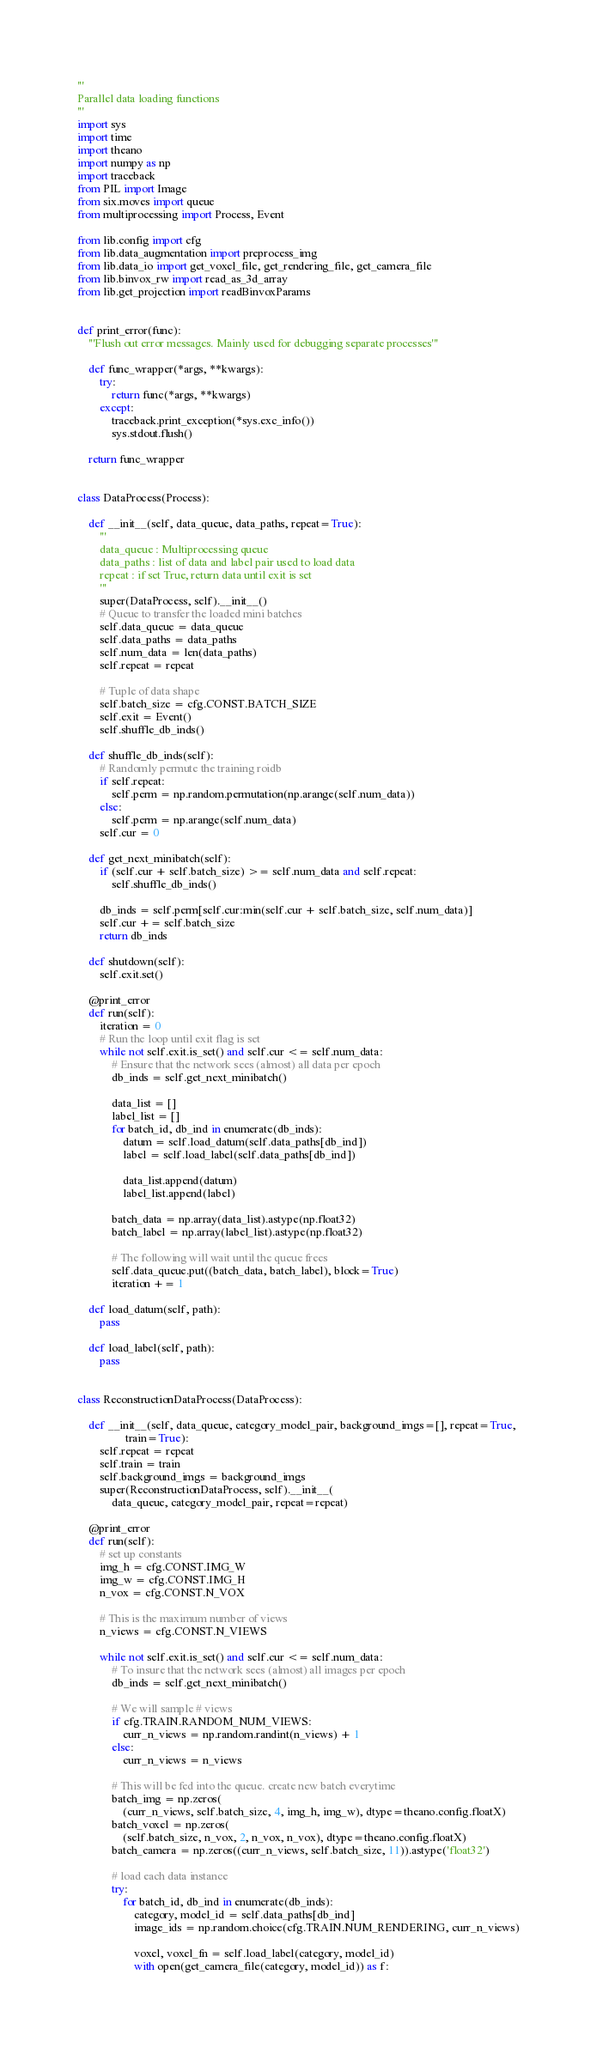Convert code to text. <code><loc_0><loc_0><loc_500><loc_500><_Python_>'''
Parallel data loading functions
'''
import sys
import time
import theano
import numpy as np
import traceback
from PIL import Image
from six.moves import queue
from multiprocessing import Process, Event

from lib.config import cfg
from lib.data_augmentation import preprocess_img
from lib.data_io import get_voxel_file, get_rendering_file, get_camera_file
from lib.binvox_rw import read_as_3d_array
from lib.get_projection import readBinvoxParams


def print_error(func):
    '''Flush out error messages. Mainly used for debugging separate processes'''

    def func_wrapper(*args, **kwargs):
        try:
            return func(*args, **kwargs)
        except:
            traceback.print_exception(*sys.exc_info())
            sys.stdout.flush()

    return func_wrapper


class DataProcess(Process):

    def __init__(self, data_queue, data_paths, repeat=True):
        '''
        data_queue : Multiprocessing queue
        data_paths : list of data and label pair used to load data
        repeat : if set True, return data until exit is set
        '''
        super(DataProcess, self).__init__()
        # Queue to transfer the loaded mini batches
        self.data_queue = data_queue
        self.data_paths = data_paths
        self.num_data = len(data_paths)
        self.repeat = repeat

        # Tuple of data shape
        self.batch_size = cfg.CONST.BATCH_SIZE
        self.exit = Event()
        self.shuffle_db_inds()

    def shuffle_db_inds(self):
        # Randomly permute the training roidb
        if self.repeat:
            self.perm = np.random.permutation(np.arange(self.num_data))
        else:
            self.perm = np.arange(self.num_data)
        self.cur = 0

    def get_next_minibatch(self):
        if (self.cur + self.batch_size) >= self.num_data and self.repeat:
            self.shuffle_db_inds()

        db_inds = self.perm[self.cur:min(self.cur + self.batch_size, self.num_data)]
        self.cur += self.batch_size
        return db_inds

    def shutdown(self):
        self.exit.set()

    @print_error
    def run(self):
        iteration = 0
        # Run the loop until exit flag is set
        while not self.exit.is_set() and self.cur <= self.num_data:
            # Ensure that the network sees (almost) all data per epoch
            db_inds = self.get_next_minibatch()

            data_list = []
            label_list = []
            for batch_id, db_ind in enumerate(db_inds):
                datum = self.load_datum(self.data_paths[db_ind])
                label = self.load_label(self.data_paths[db_ind])

                data_list.append(datum)
                label_list.append(label)

            batch_data = np.array(data_list).astype(np.float32)
            batch_label = np.array(label_list).astype(np.float32)

            # The following will wait until the queue frees
            self.data_queue.put((batch_data, batch_label), block=True)
            iteration += 1

    def load_datum(self, path):
        pass

    def load_label(self, path):
        pass


class ReconstructionDataProcess(DataProcess):

    def __init__(self, data_queue, category_model_pair, background_imgs=[], repeat=True,
                 train=True):
        self.repeat = repeat
        self.train = train
        self.background_imgs = background_imgs
        super(ReconstructionDataProcess, self).__init__(
            data_queue, category_model_pair, repeat=repeat)

    @print_error
    def run(self):
        # set up constants
        img_h = cfg.CONST.IMG_W
        img_w = cfg.CONST.IMG_H
        n_vox = cfg.CONST.N_VOX

        # This is the maximum number of views
        n_views = cfg.CONST.N_VIEWS

        while not self.exit.is_set() and self.cur <= self.num_data:
            # To insure that the network sees (almost) all images per epoch
            db_inds = self.get_next_minibatch()

            # We will sample # views
            if cfg.TRAIN.RANDOM_NUM_VIEWS:
                curr_n_views = np.random.randint(n_views) + 1
            else:
                curr_n_views = n_views

            # This will be fed into the queue. create new batch everytime
            batch_img = np.zeros(
                (curr_n_views, self.batch_size, 4, img_h, img_w), dtype=theano.config.floatX)
            batch_voxel = np.zeros(
                (self.batch_size, n_vox, 2, n_vox, n_vox), dtype=theano.config.floatX)
            batch_camera = np.zeros((curr_n_views, self.batch_size, 11)).astype('float32')

            # load each data instance
            try:
                for batch_id, db_ind in enumerate(db_inds):
                    category, model_id = self.data_paths[db_ind]
                    image_ids = np.random.choice(cfg.TRAIN.NUM_RENDERING, curr_n_views)

                    voxel, voxel_fn = self.load_label(category, model_id)
                    with open(get_camera_file(category, model_id)) as f:</code> 